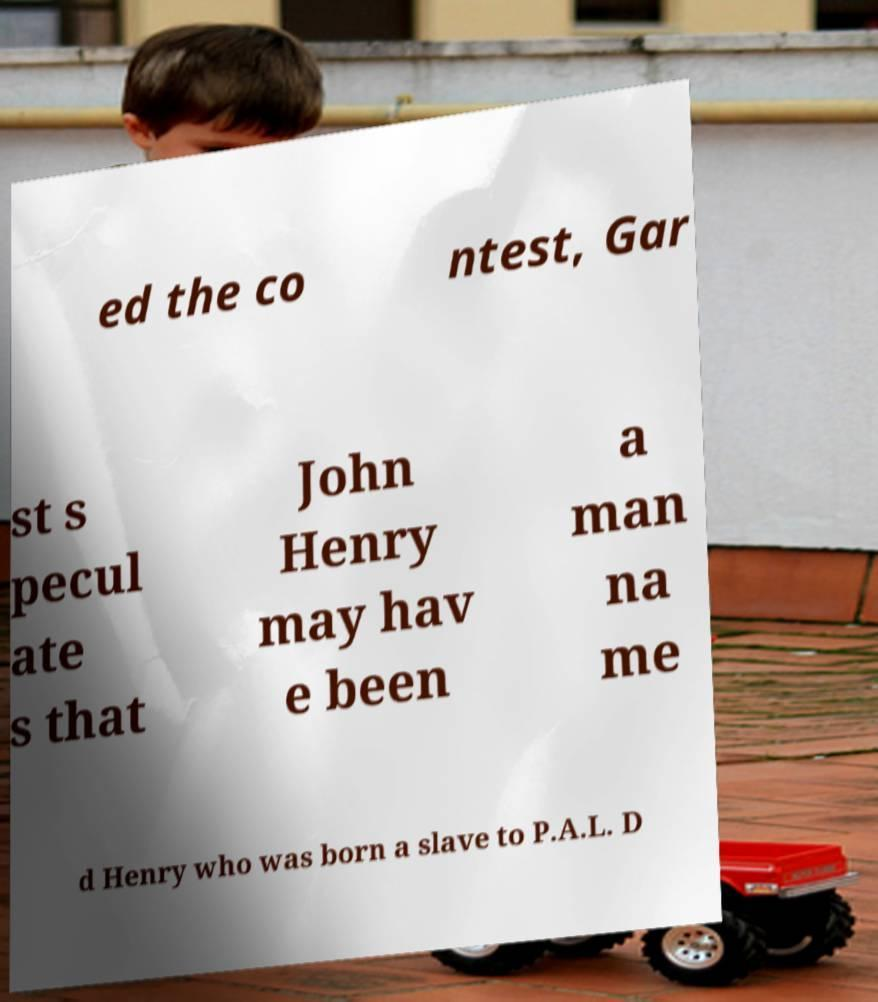Can you accurately transcribe the text from the provided image for me? ed the co ntest, Gar st s pecul ate s that John Henry may hav e been a man na me d Henry who was born a slave to P.A.L. D 